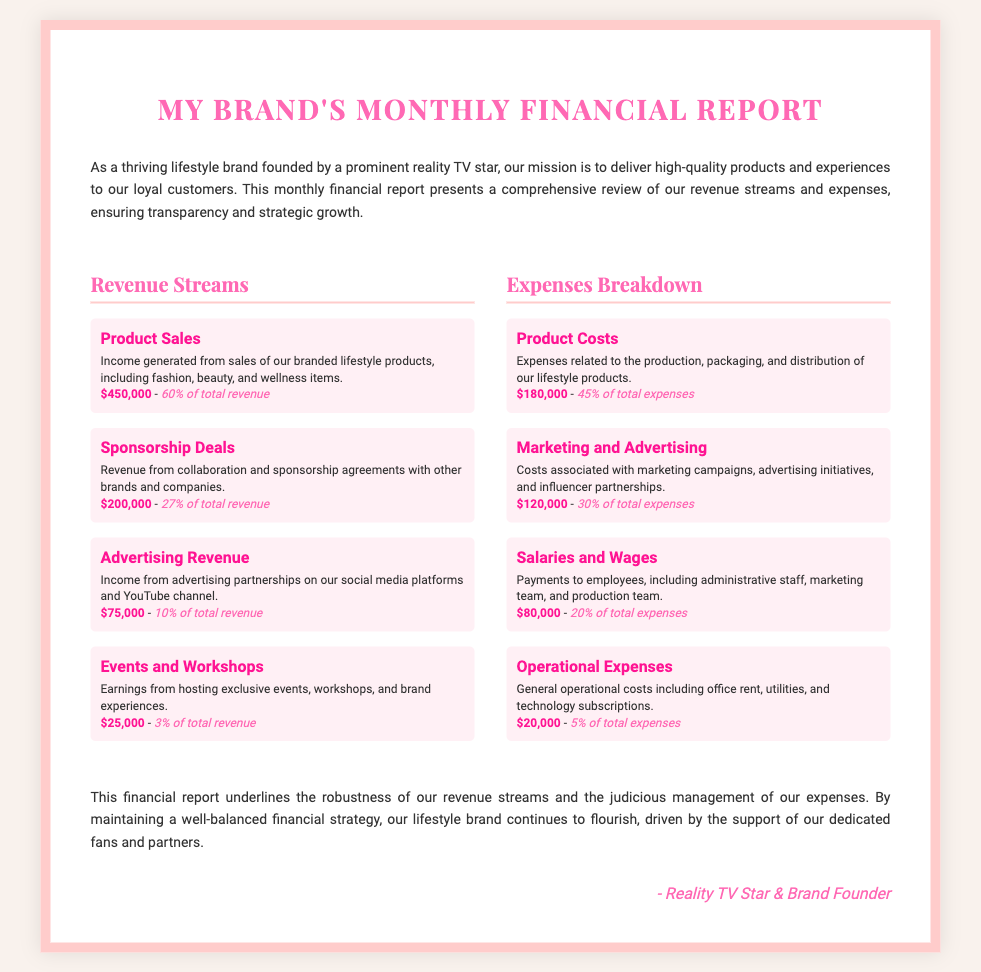What is the total revenue? The total revenue is the sum of all revenue sources: $450,000 + $200,000 + $75,000 + $25,000 = $750,000.
Answer: $750,000 What percentage of total revenue comes from product sales? According to the document, product sales account for 60% of total revenue.
Answer: 60% What is the highest revenue stream? The highest revenue stream is product sales, which are $450,000.
Answer: $450,000 How much is spent on salaries and wages? The document states that salaries and wages amount to $80,000, making it a significant expense.
Answer: $80,000 What percentage of expenses does marketing and advertising represent? Marketing and advertising costs represent 30% of total expenses as per the breakdown.
Answer: 30% What is the lowest revenue stream? The lowest revenue stream is from events and workshops, generating $25,000.
Answer: $25,000 What fraction of total expenses goes to operational expenses? Operational expenses constitute 5% of total expenses according to the document.
Answer: 5% How much revenue is generated from sponsorship deals? The document specifies that sponsorship deals generate $200,000 in revenue.
Answer: $200,000 What is the total amount spent on product costs? The total spent on product costs is $180,000 as mentioned in the expenses breakdown.
Answer: $180,000 